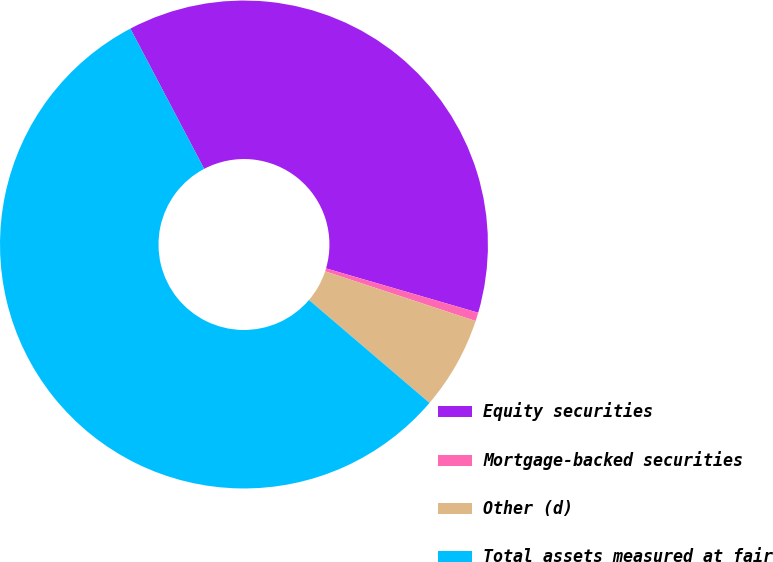Convert chart. <chart><loc_0><loc_0><loc_500><loc_500><pie_chart><fcel>Equity securities<fcel>Mortgage-backed securities<fcel>Other (d)<fcel>Total assets measured at fair<nl><fcel>37.22%<fcel>0.57%<fcel>6.17%<fcel>56.04%<nl></chart> 